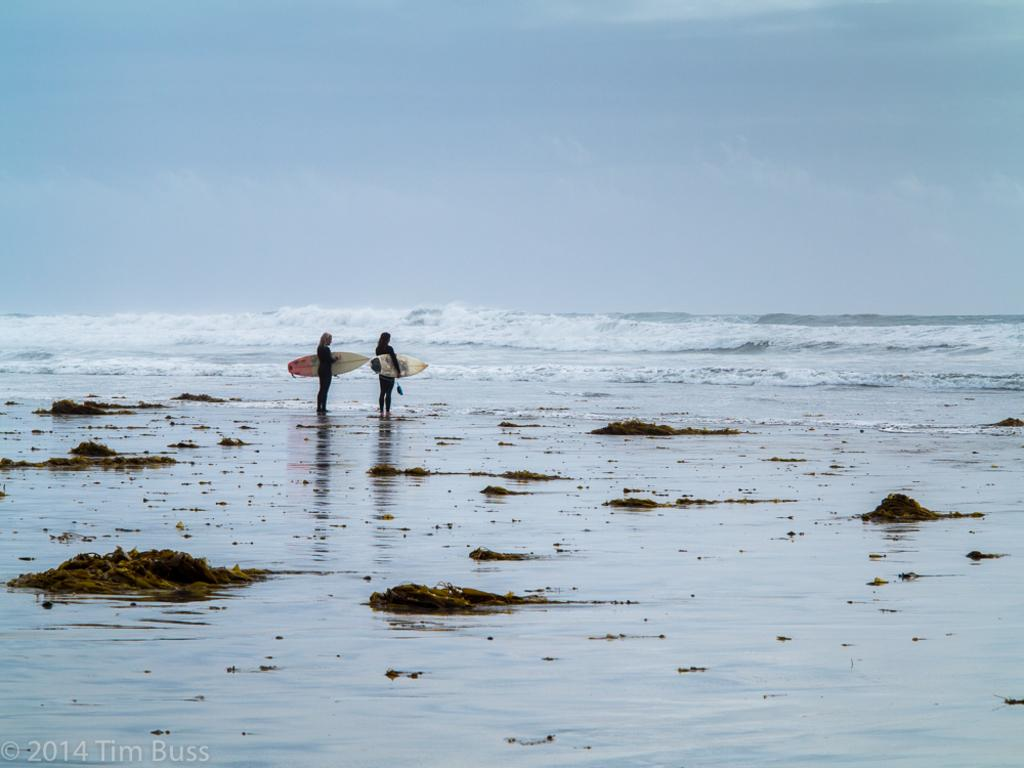How many people are in the image? There are two people in the image. What are the people doing in the image? The people are standing and holding surfing boards. What can be seen in the background of the image? There is water visible in the image. What type of vase can be seen in the image? There is no vase present in the image. How is the rice being prepared in the image? There is no rice or any cooking activity present in the image. 